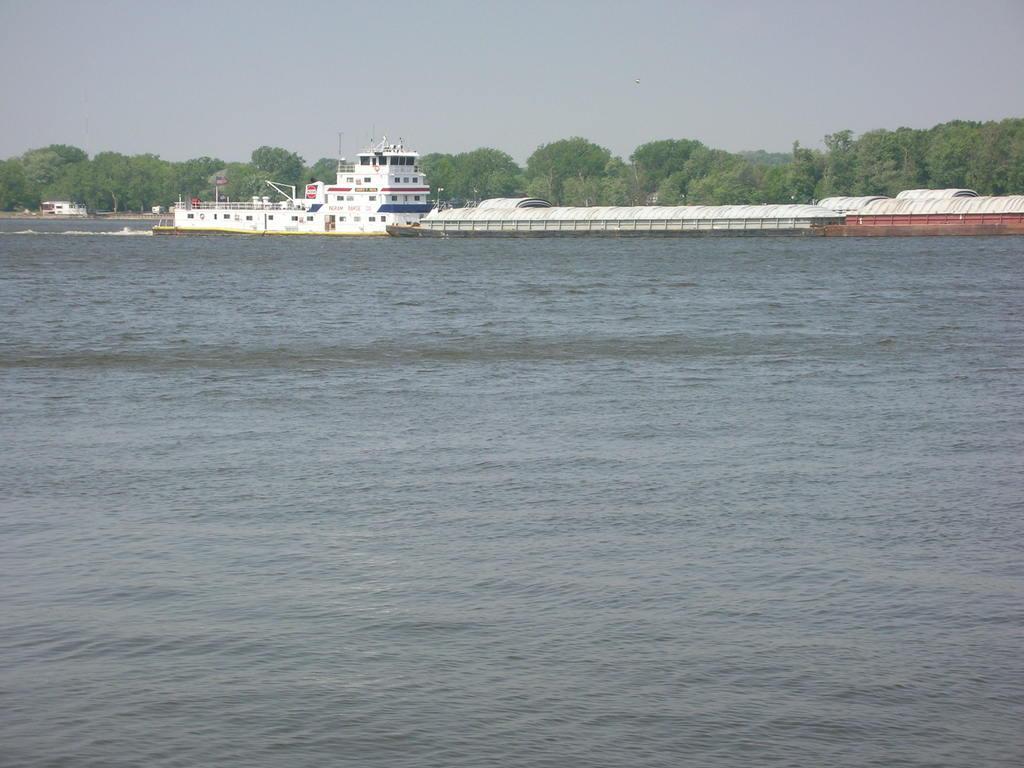Describe this image in one or two sentences. In the foreground of the picture there is a water body. In the center of the picture there are ships and trees. Sky is cloudy. 